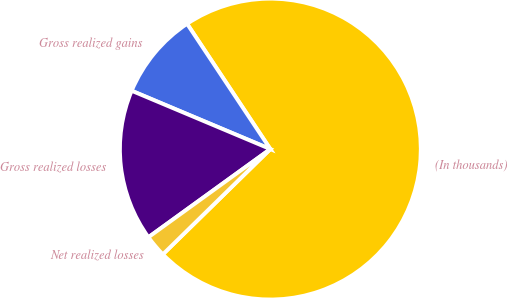<chart> <loc_0><loc_0><loc_500><loc_500><pie_chart><fcel>(In thousands)<fcel>Gross realized gains<fcel>Gross realized losses<fcel>Net realized losses<nl><fcel>72.01%<fcel>9.33%<fcel>16.3%<fcel>2.37%<nl></chart> 